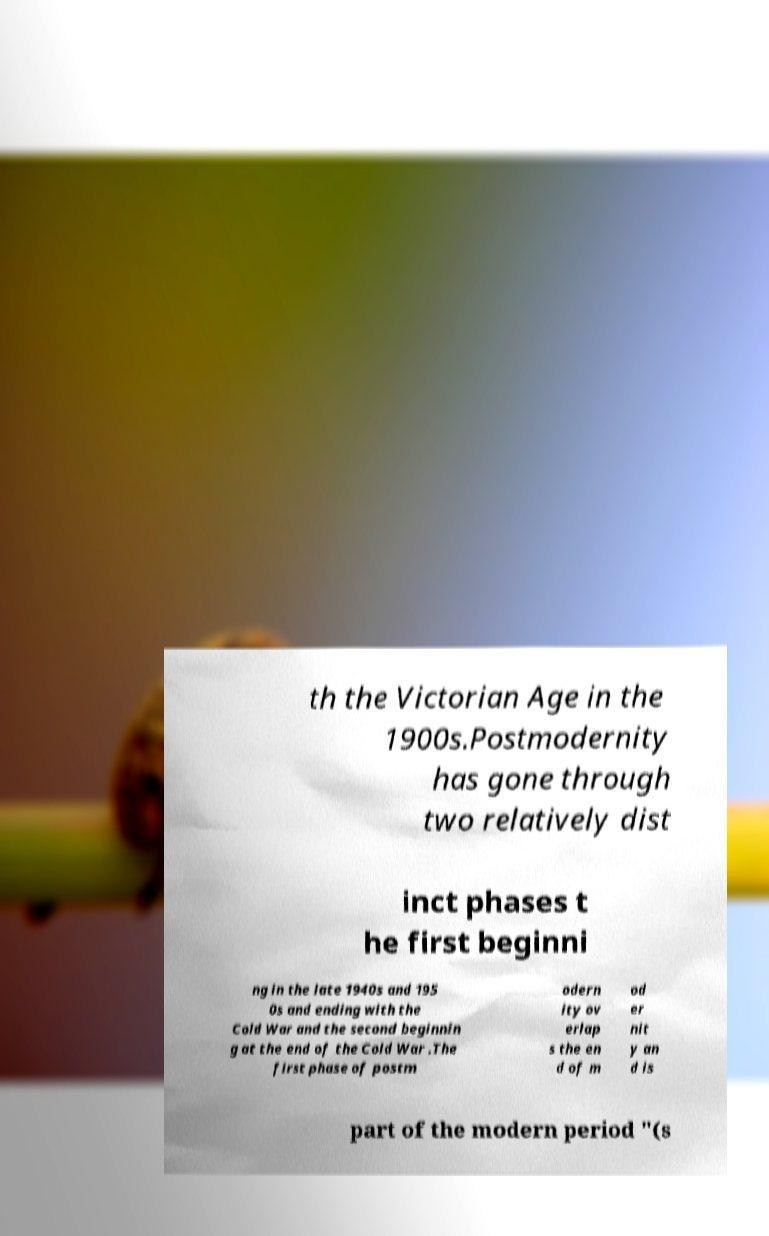Please read and relay the text visible in this image. What does it say? th the Victorian Age in the 1900s.Postmodernity has gone through two relatively dist inct phases t he first beginni ng in the late 1940s and 195 0s and ending with the Cold War and the second beginnin g at the end of the Cold War .The first phase of postm odern ity ov erlap s the en d of m od er nit y an d is part of the modern period "(s 